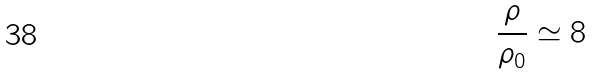Convert formula to latex. <formula><loc_0><loc_0><loc_500><loc_500>\frac { \rho } { \rho _ { 0 } } \simeq 8</formula> 